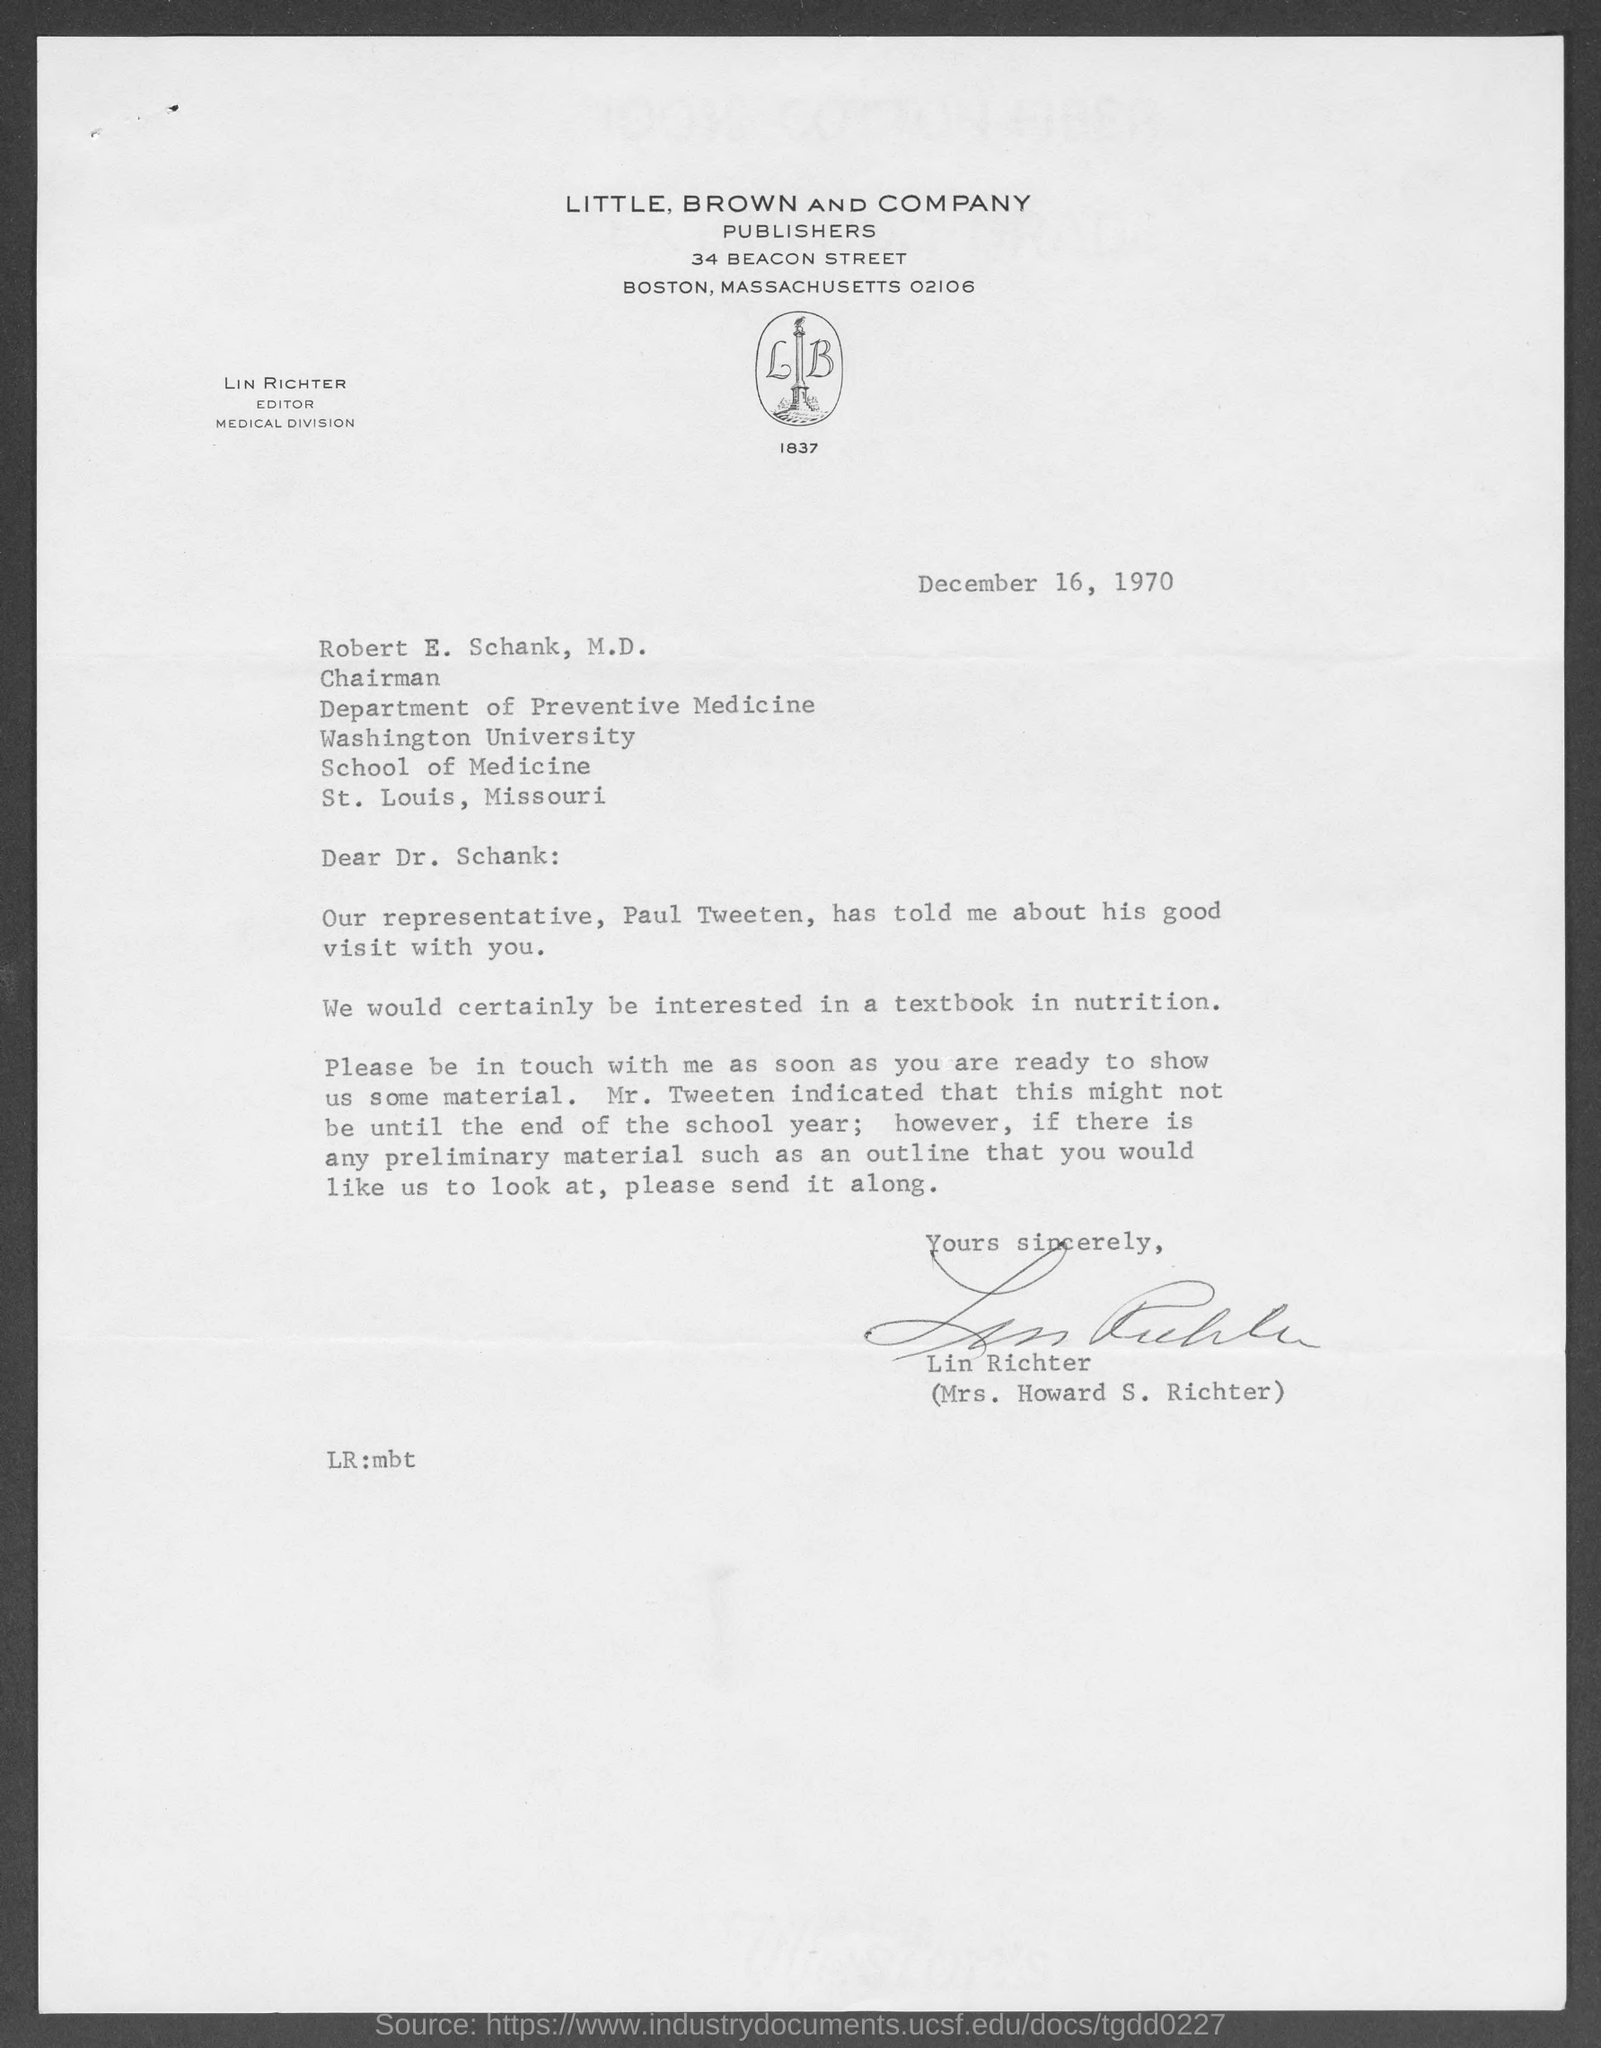Which publishers are mentioned?
Keep it short and to the point. LITTLE, BROWN AND COMPANY. Who is the editor of Medical Division?
Your response must be concise. LIN RICHTER. When is the document dated?
Your answer should be very brief. December 16, 1970. 